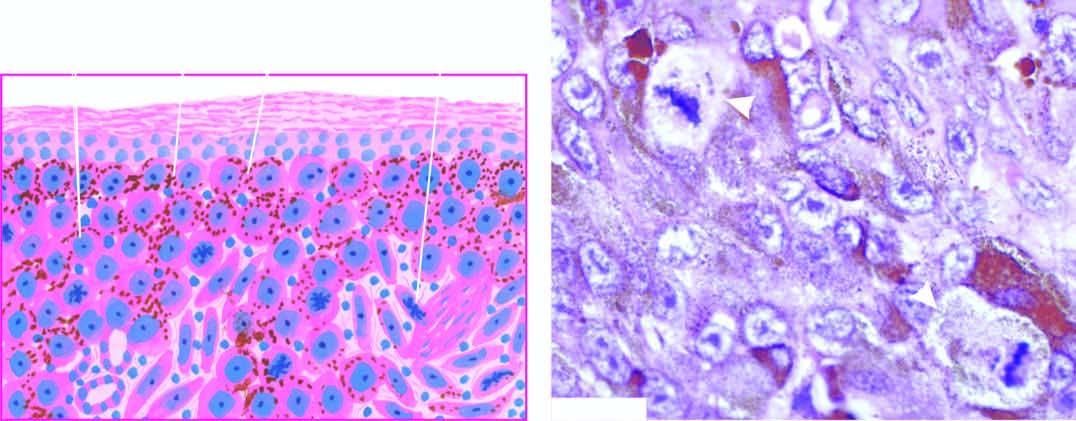what are seen as solid masses in the dermis?
Answer the question using a single word or phrase. Tumour cells resembling epithelioid cells with pleomorphic nuclei and prominent nucleoli 